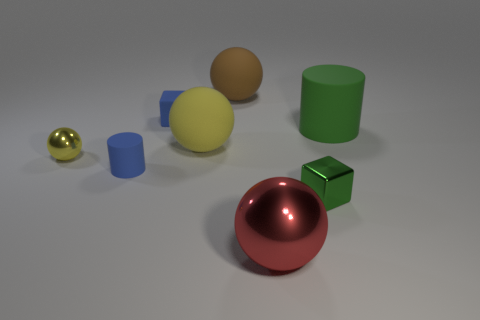What might be the purpose of arranging these objects together in this manner? This arrangement might be for a visual study in geometry and color perception, showcasing how light interacts with different colored surfaces and shapes. Could these objects be used for some kind of educational purpose? Yes, they could serve as teaching tools in a lesson about geometry, volume, and the physics of light and reflection. 